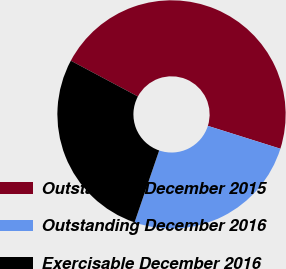Convert chart. <chart><loc_0><loc_0><loc_500><loc_500><pie_chart><fcel>Outstanding December 2015<fcel>Outstanding December 2016<fcel>Exercisable December 2016<nl><fcel>47.06%<fcel>25.39%<fcel>27.55%<nl></chart> 